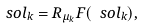Convert formula to latex. <formula><loc_0><loc_0><loc_500><loc_500>\ s o l _ { k } = R _ { \mu _ { k } } F ( \ s o l _ { k } ) ,</formula> 